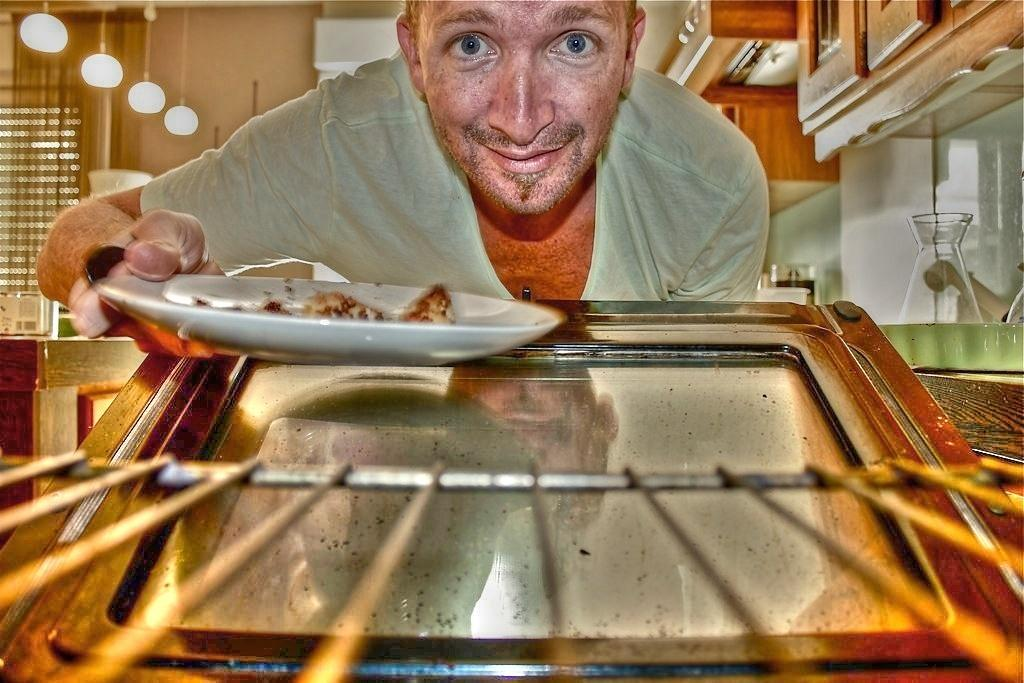What is the man in the image doing? The man is holding a plate in his hand and has opened an oven door. What might the man be preparing in the image? It is not explicitly stated, but the man's actions suggest he might be preparing food. What type of lighting is present in the image? There are lights visible in the image. What type of storage is present in the image? There are cupboards in the image. What is on the countertop in the image? There are vessels on the countertop. What type of window treatment is present in the image? There are blinds on the window. How does the man express his pain in the image? There is no indication of pain in the image; the man is holding a plate and opening an oven door. What type of ring is the man wearing in the image? There is no ring visible on the man's hand in the image. 